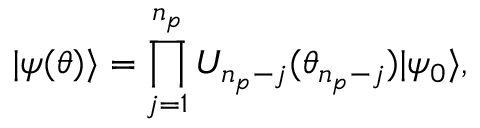<formula> <loc_0><loc_0><loc_500><loc_500>{ | { \psi ( { \theta } ) } \rangle } = \prod _ { j = 1 } ^ { n _ { p } } U _ { n _ { p } - j } ( \theta _ { n _ { p } - j } ) { | { \psi _ { 0 } } \rangle } ,</formula> 